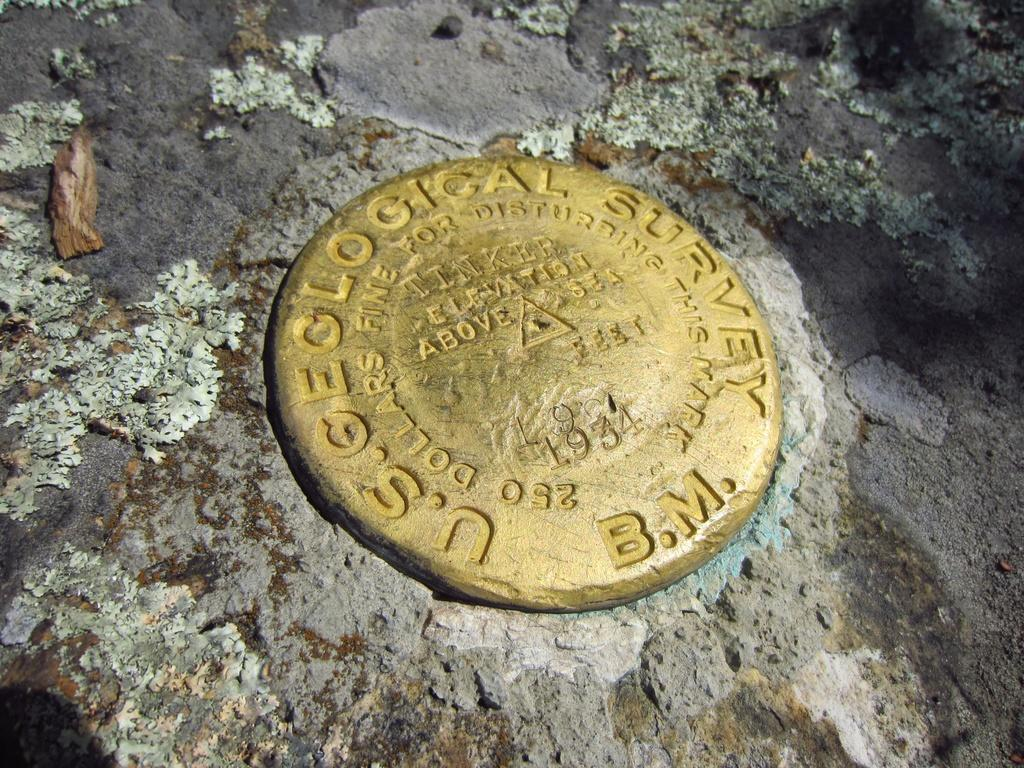<image>
Describe the image concisely. U.S Geological survey gold in rocks b.m type of coin 